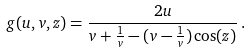<formula> <loc_0><loc_0><loc_500><loc_500>g ( u , v , z ) = \frac { 2 u } { v + \frac { 1 } { v } - ( v - \frac { 1 } { v } ) \cos ( z ) } \, .</formula> 